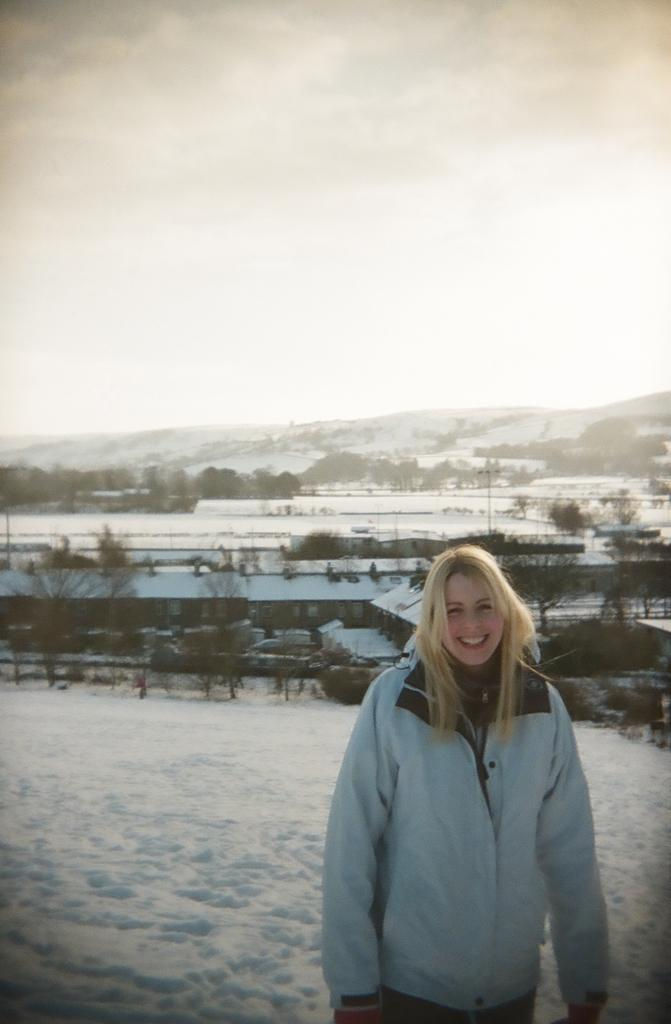Who is present in the image? There is a woman in the image. What is the woman's expression? The woman is smiling. What is the main feature in the middle of the image? There is snow in the middle of the image. What can be seen in the background of the image? There are vehicles, buildings, and trees in the background of the image. We then formulate questions that focus on the location and characteristics of these subjects and objects, ensuring that each question can be answered definitively with the information given. We avoid yes/no questions and ensure that the language is simple and clear. What type of blood is visible on the woman's face in the image? There is no blood visible on the woman's face in the image. How many trucks are parked near the buildings in the image? The image does not specify the number of trucks or their location near the buildings. What is the woman using to carry the yoke in the image? There is no yoke present in the image. 